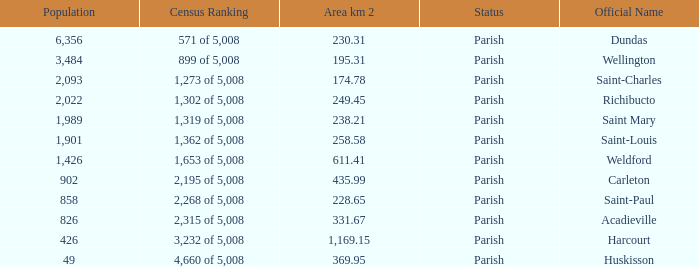For Saint-Paul parish, if it has an area of over 228.65 kilometers how many people live there? 0.0. 